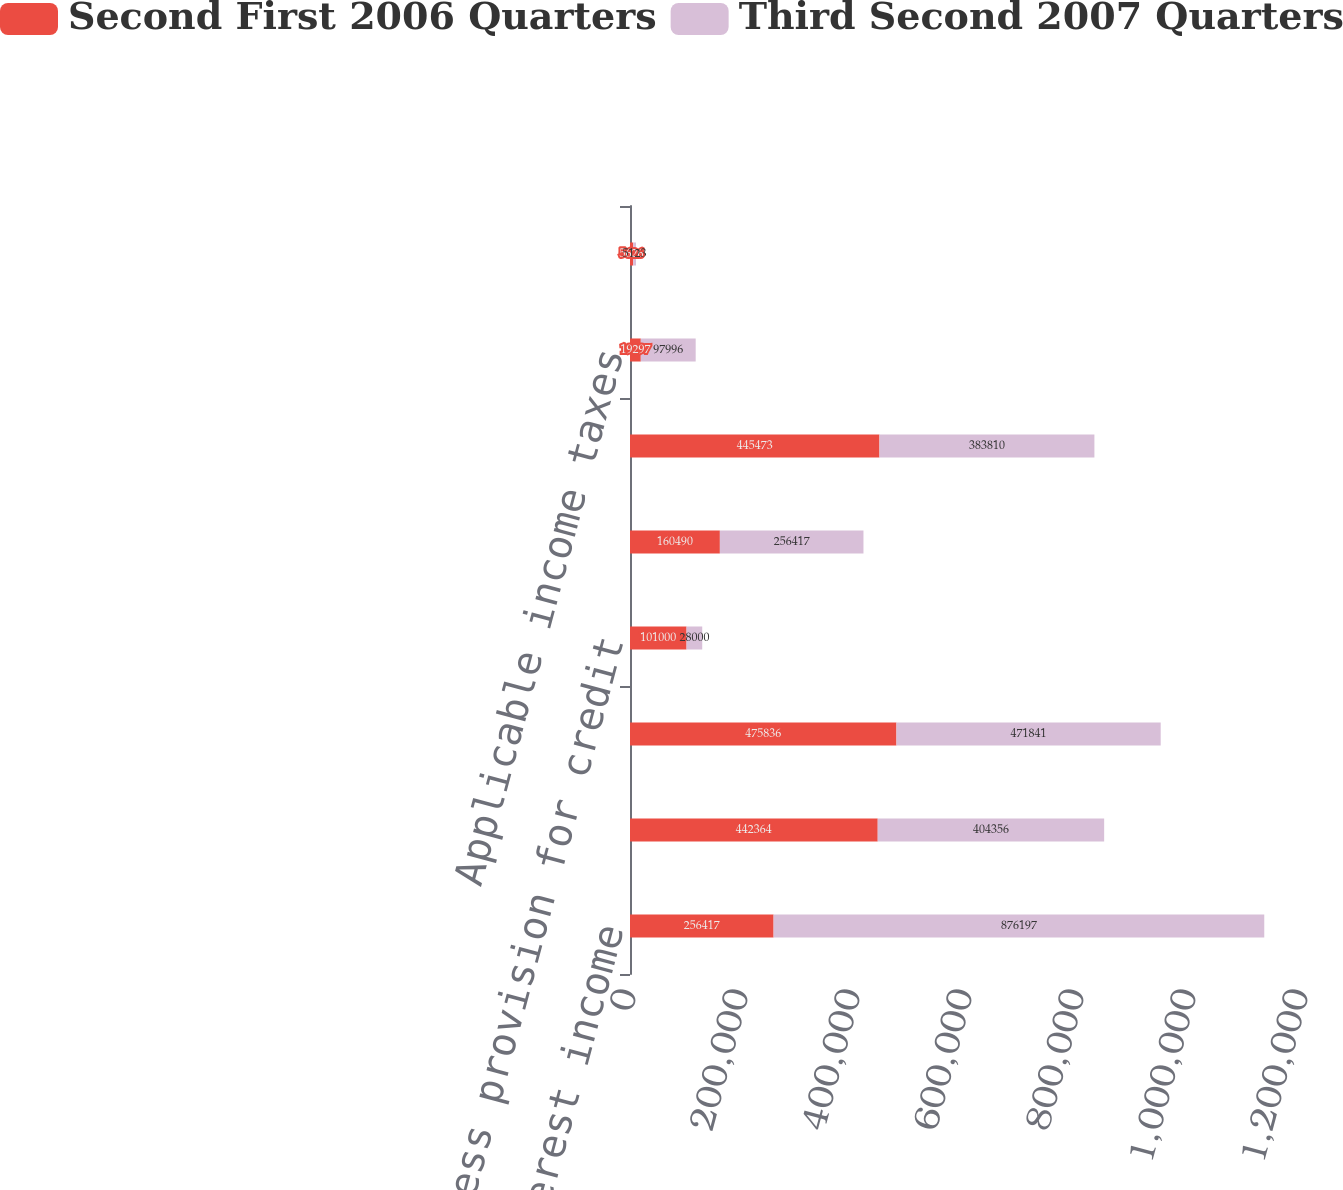Convert chart. <chart><loc_0><loc_0><loc_500><loc_500><stacked_bar_chart><ecel><fcel>Interest income<fcel>Interest expense<fcel>Net interest income<fcel>Less provision for credit<fcel>Other income<fcel>Less other expense<fcel>Applicable income taxes<fcel>Taxable-equivalent adjustment<nl><fcel>Second First 2006 Quarters<fcel>256417<fcel>442364<fcel>475836<fcel>101000<fcel>160490<fcel>445473<fcel>19297<fcel>5626<nl><fcel>Third Second 2007 Quarters<fcel>876197<fcel>404356<fcel>471841<fcel>28000<fcel>256417<fcel>383810<fcel>97996<fcel>5123<nl></chart> 